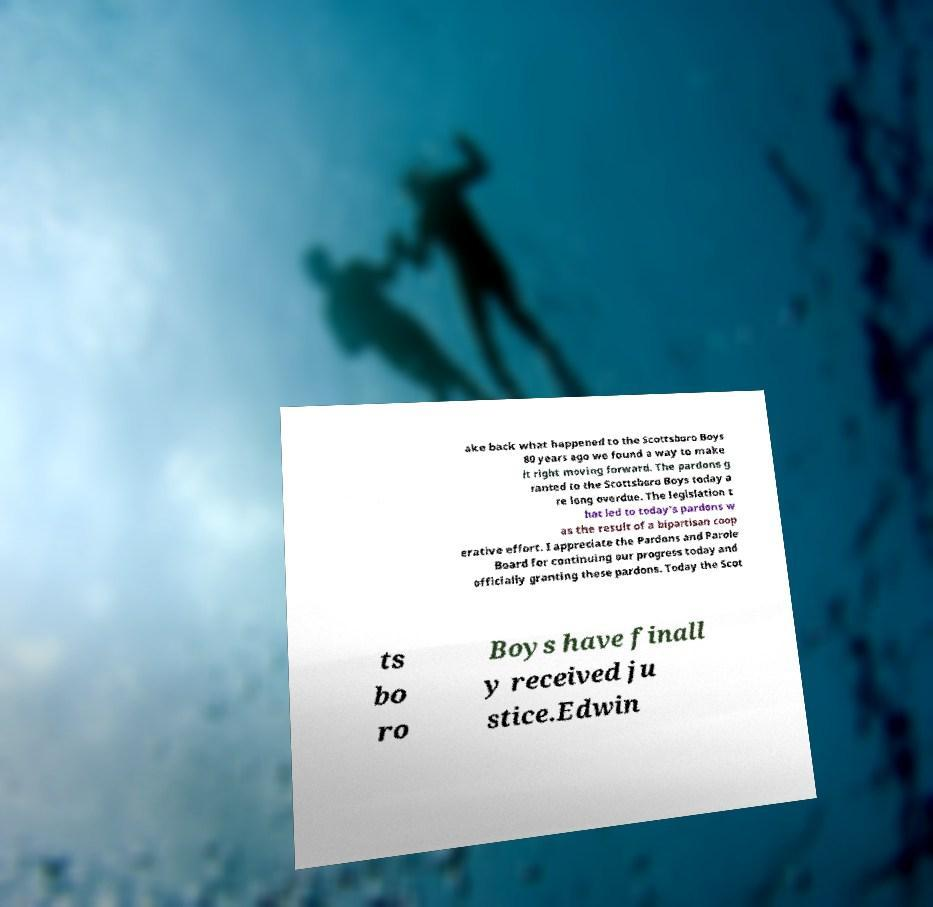Could you extract and type out the text from this image? ake back what happened to the Scottsboro Boys 80 years ago we found a way to make it right moving forward. The pardons g ranted to the Scottsboro Boys today a re long overdue. The legislation t hat led to today's pardons w as the result of a bipartisan coop erative effort. I appreciate the Pardons and Parole Board for continuing our progress today and officially granting these pardons. Today the Scot ts bo ro Boys have finall y received ju stice.Edwin 